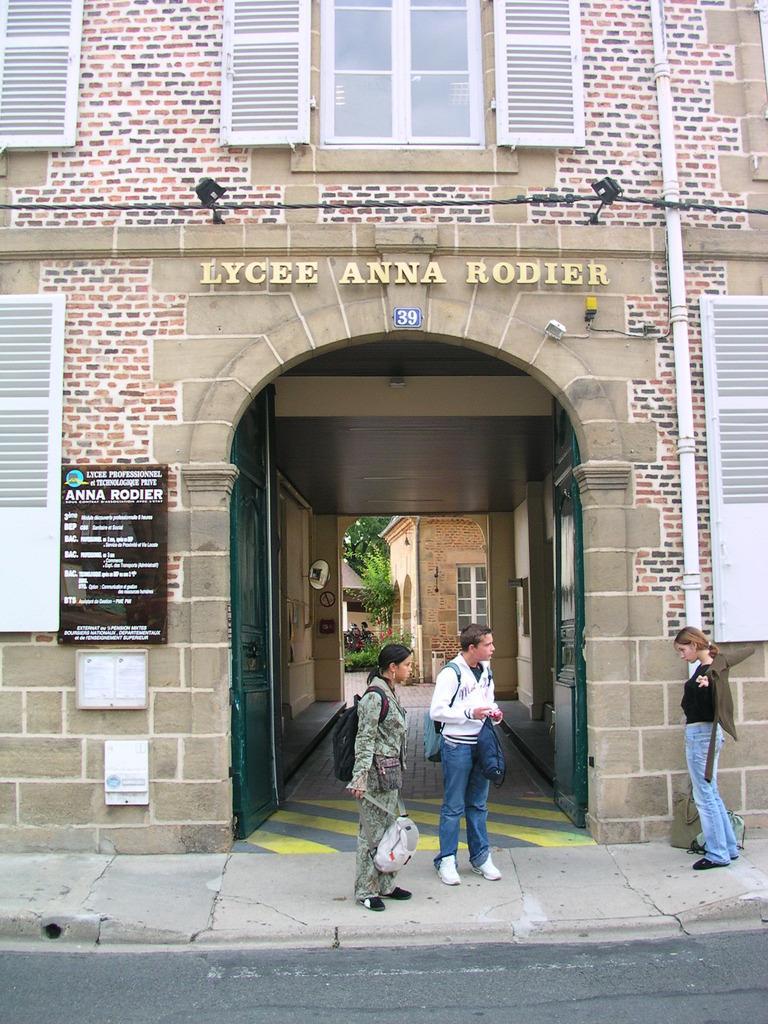How would you summarize this image in a sentence or two? On the right side, there is a woman in a black color dress, wearing a jacket on the footpath. In front of her, there are two persons standing on the footpath. In the background, there is a hoarding and there is a board on the wall of the building which is having windows, there are plants, there is a tree and there is another building. 